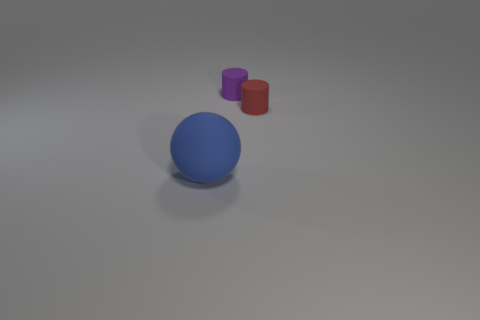Add 3 small purple cylinders. How many objects exist? 6 Add 2 rubber cylinders. How many rubber cylinders are left? 4 Add 2 cylinders. How many cylinders exist? 4 Subtract 0 green cylinders. How many objects are left? 3 Subtract all balls. How many objects are left? 2 Subtract all tiny purple metallic things. Subtract all rubber objects. How many objects are left? 0 